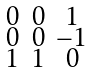Convert formula to latex. <formula><loc_0><loc_0><loc_500><loc_500>\begin{smallmatrix} 0 & 0 & 1 \\ 0 & 0 & - 1 \\ 1 & 1 & 0 \end{smallmatrix}</formula> 